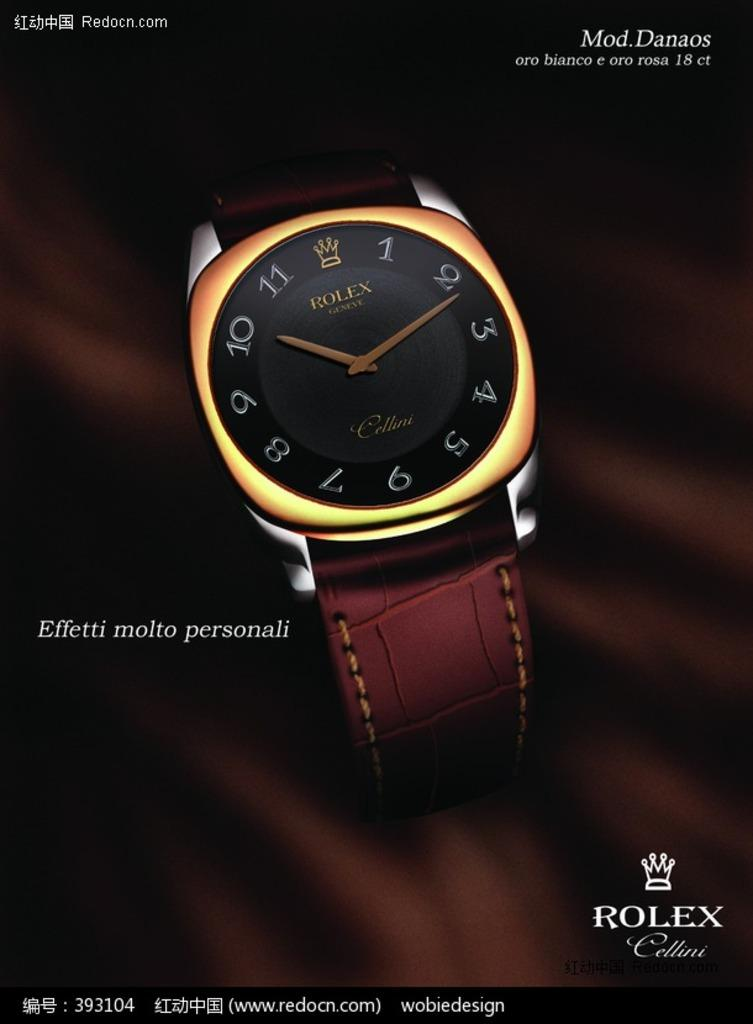<image>
Render a clear and concise summary of the photo. A gold and black RoLex watch sits on top of brown silk 